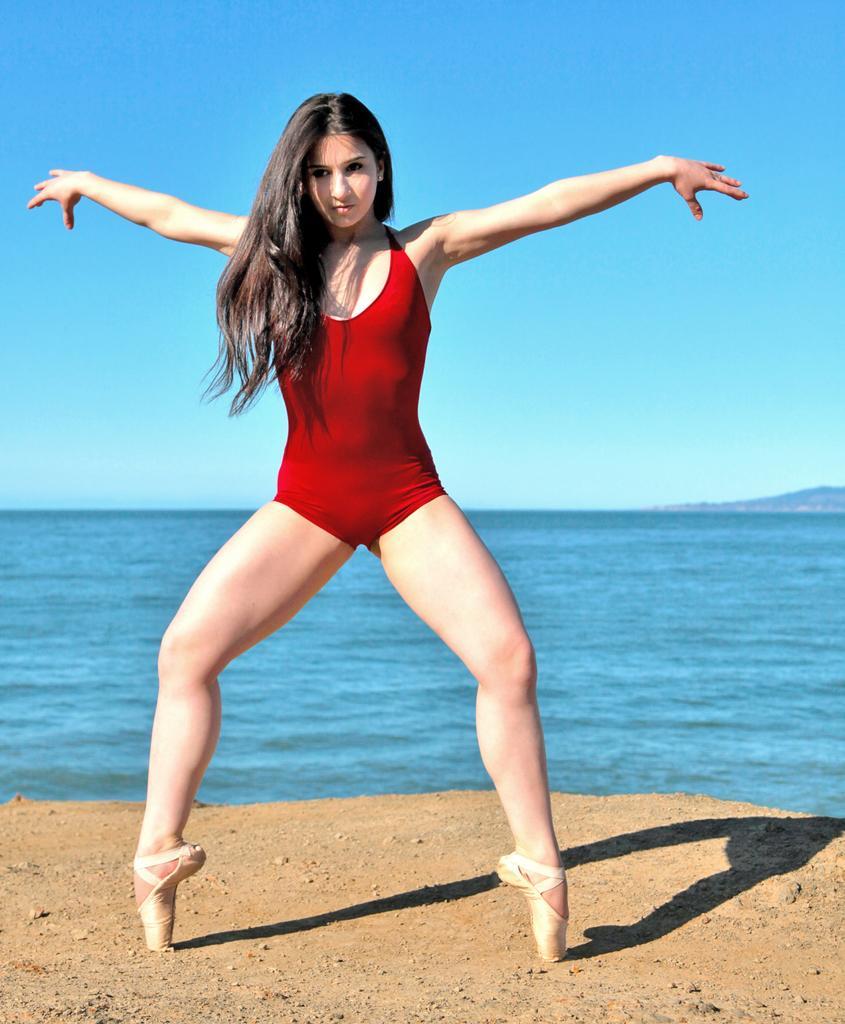How would you summarize this image in a sentence or two? This picture shows a woman standing on the toes and we see water and a blue sky. 